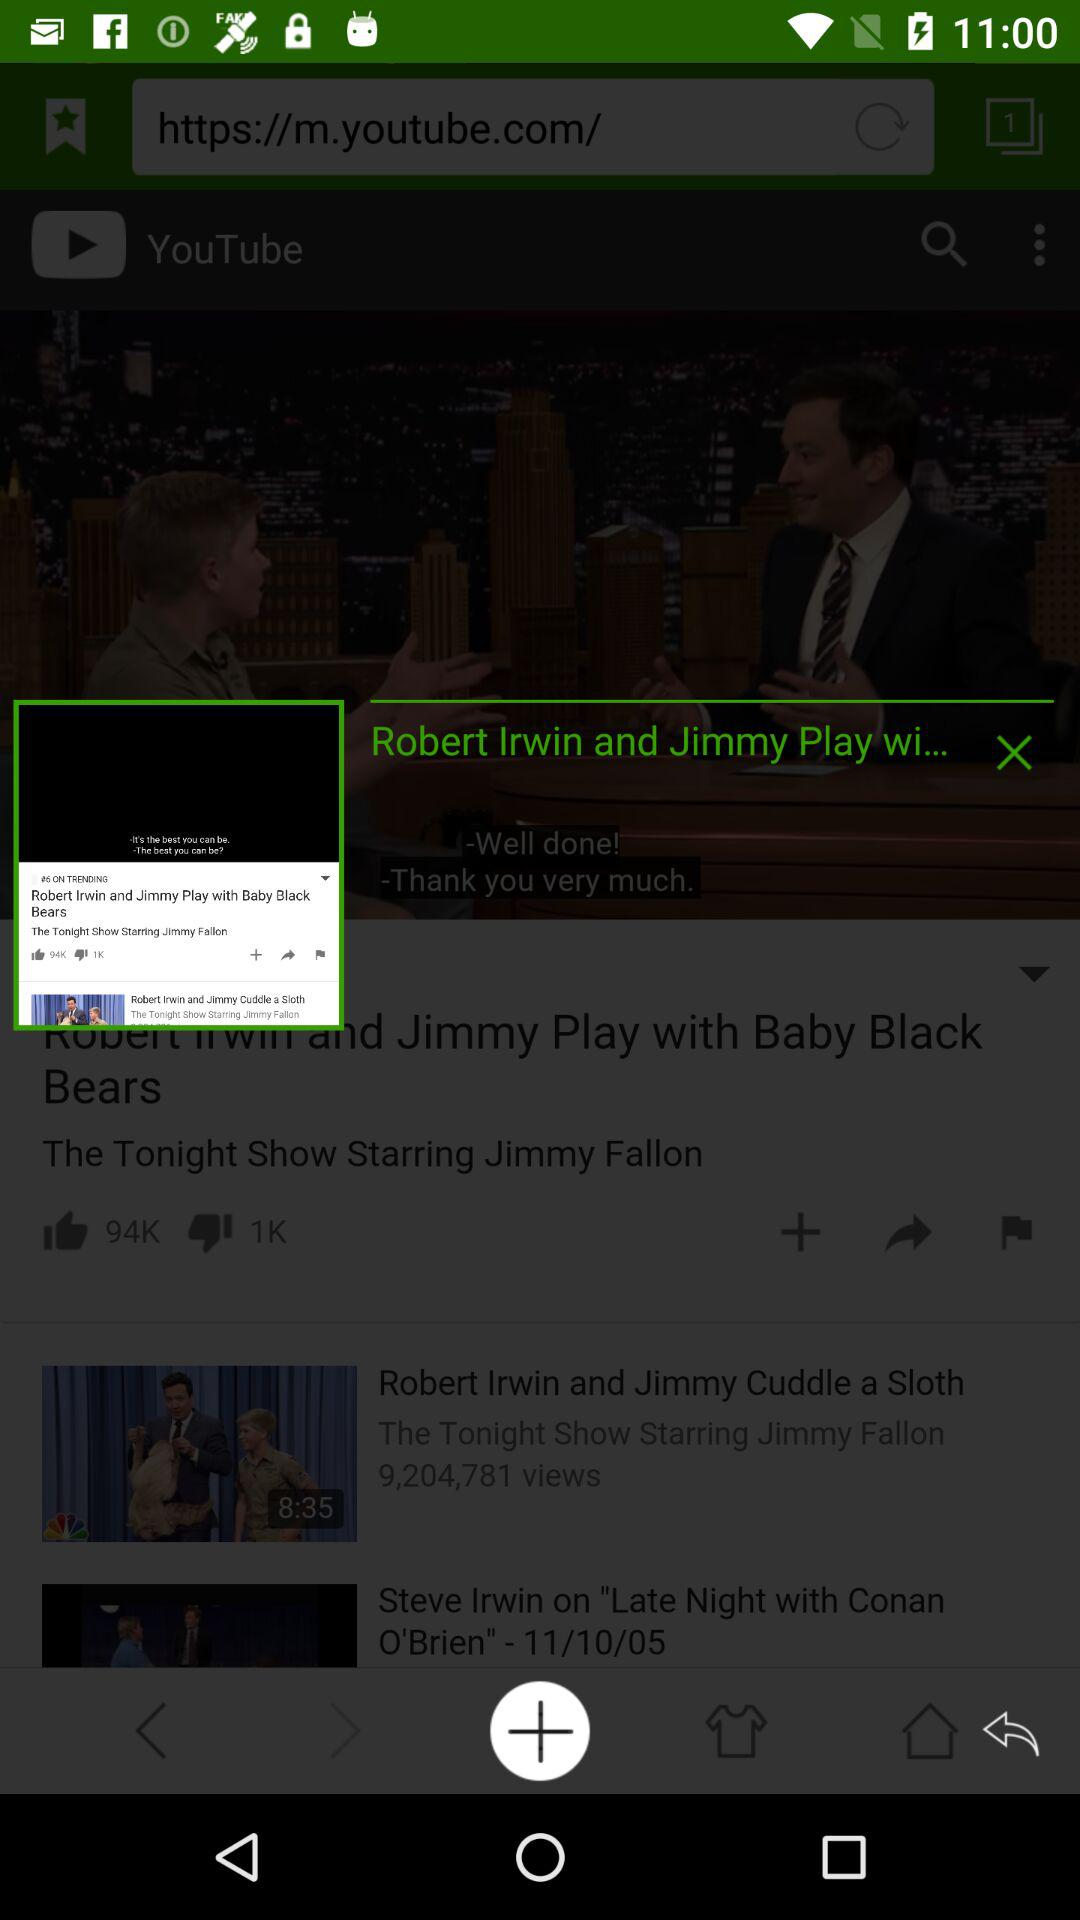How many views are there for the "Robert Irwin and Jimmy Cuddle a Sloth" video? There are 9,204,781 views for the "Robert Irwin and Jimmy Cuddle a Sloth" video. 